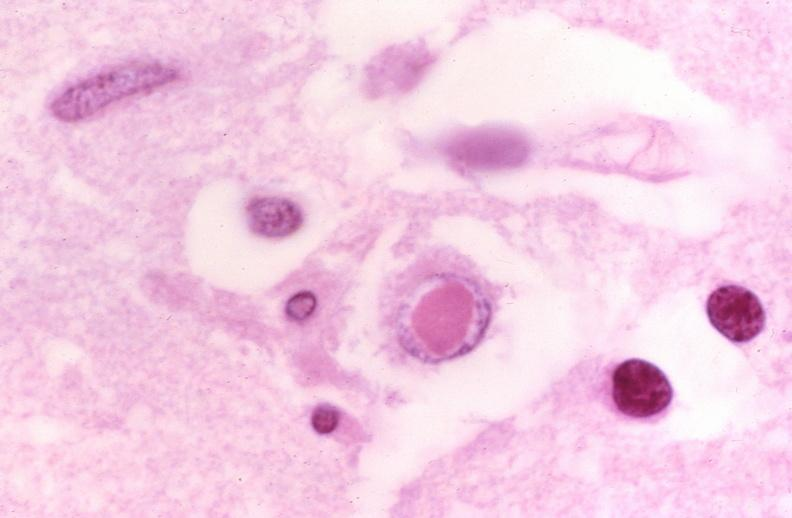what does this image show?
Answer the question using a single word or phrase. Brain 